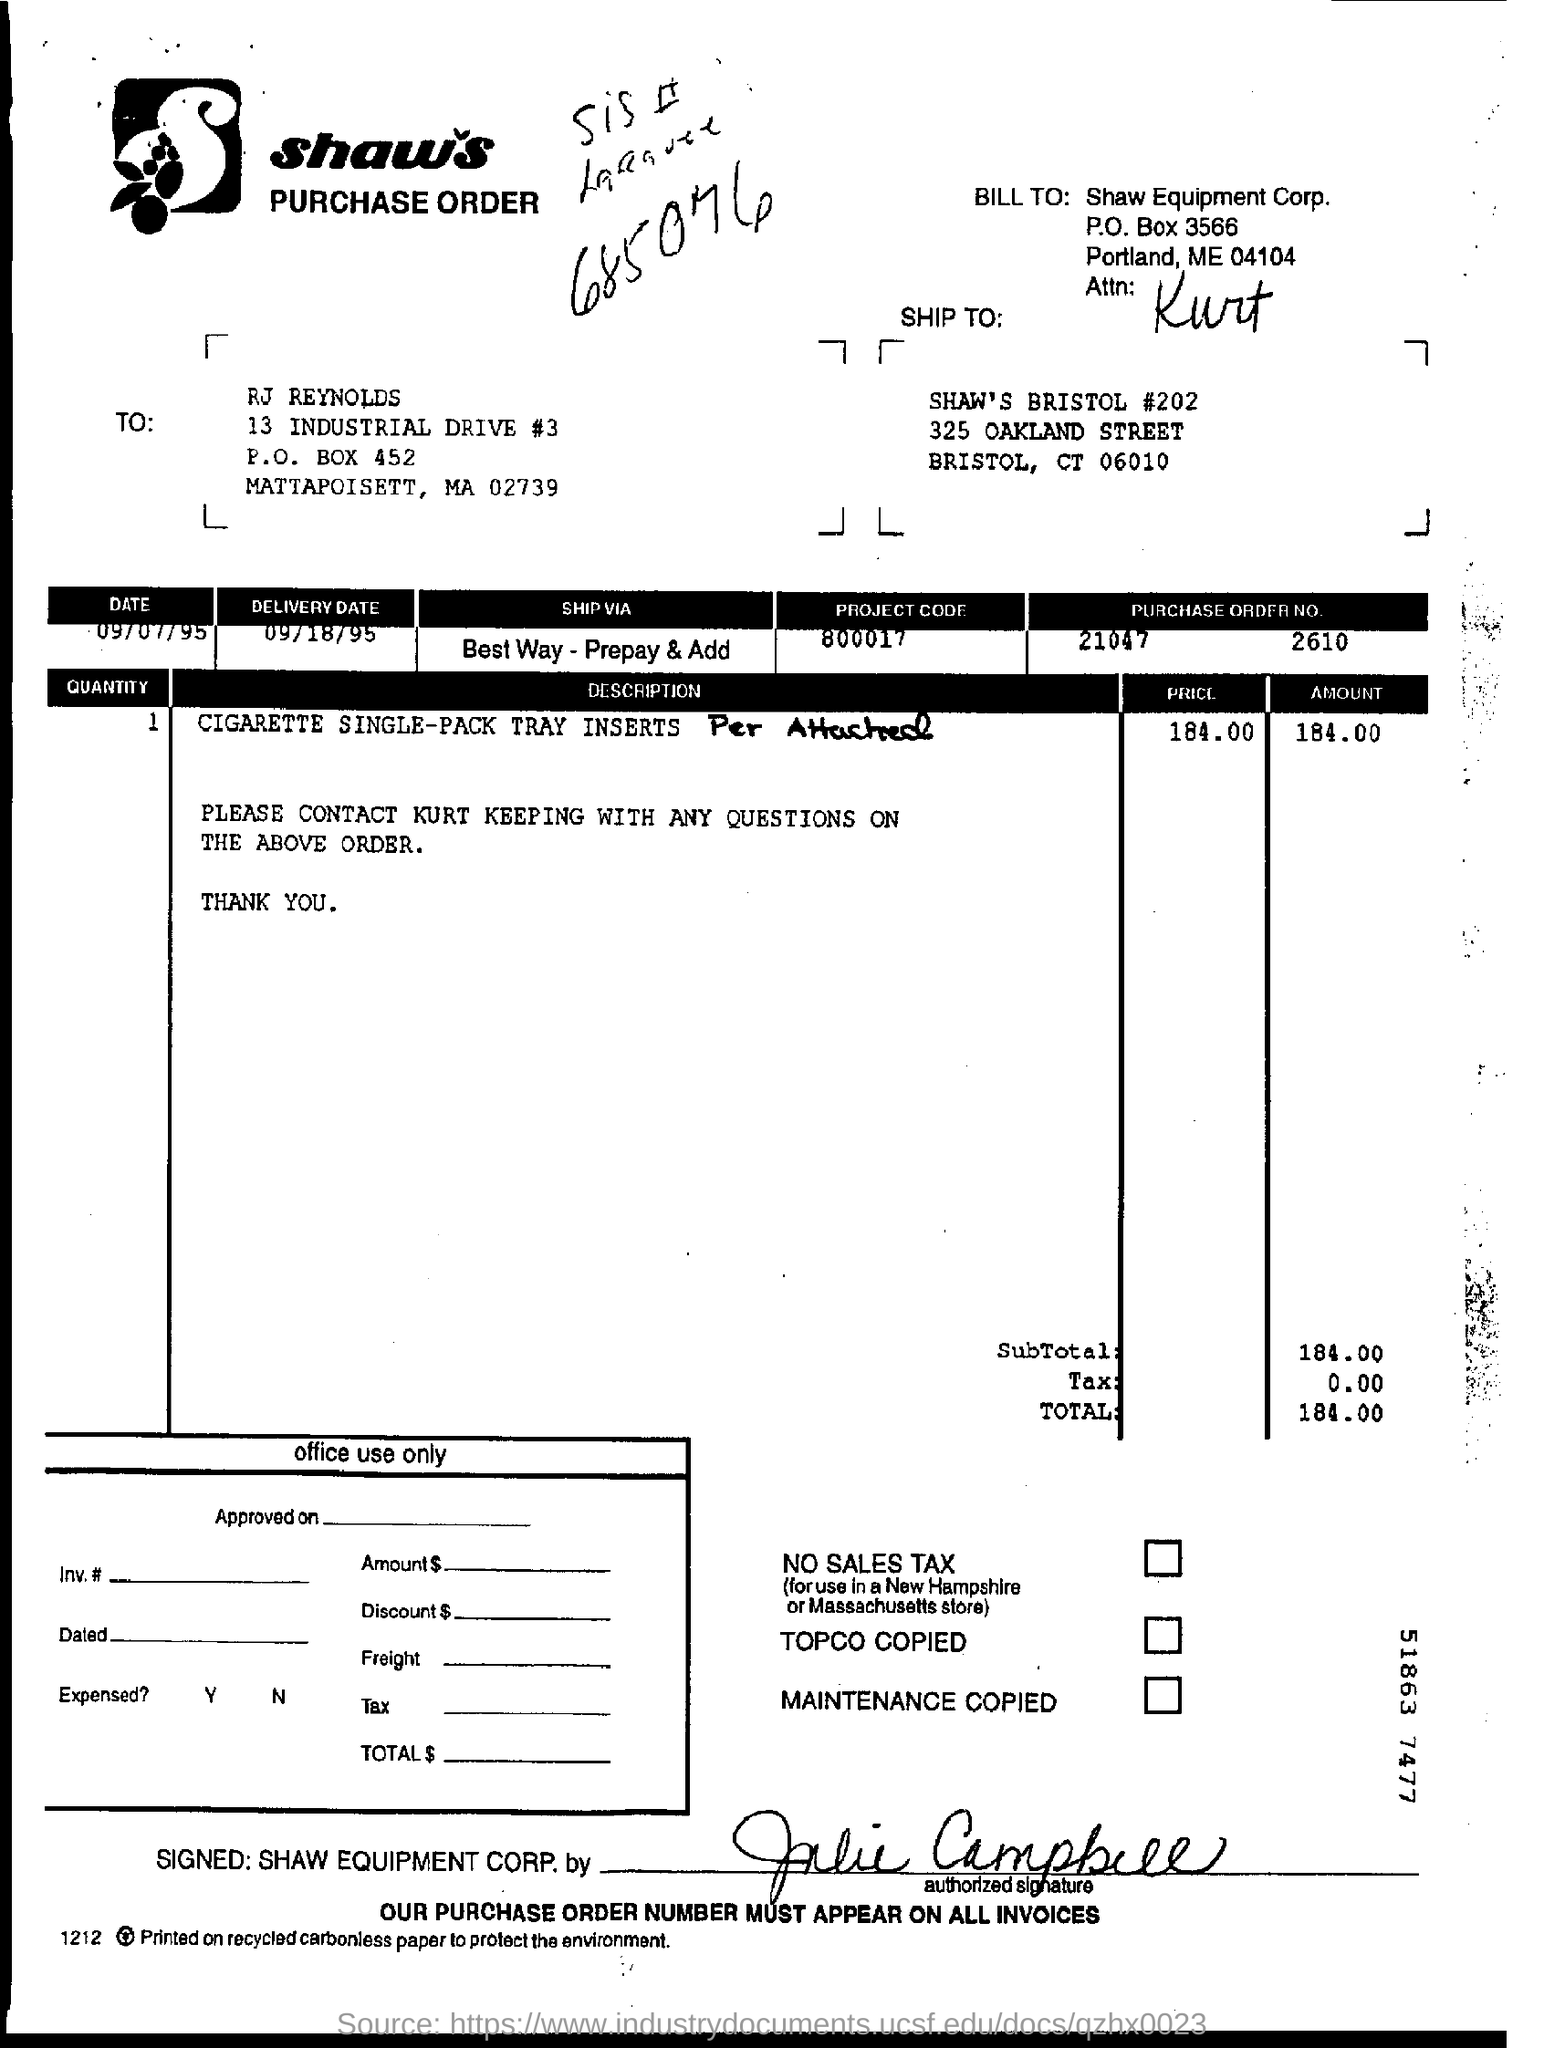Mention a couple of crucial points in this snapshot. The purchase order number is 21047 and the second part is 2610. On September 18th, 1995, the delivery date was provided. 